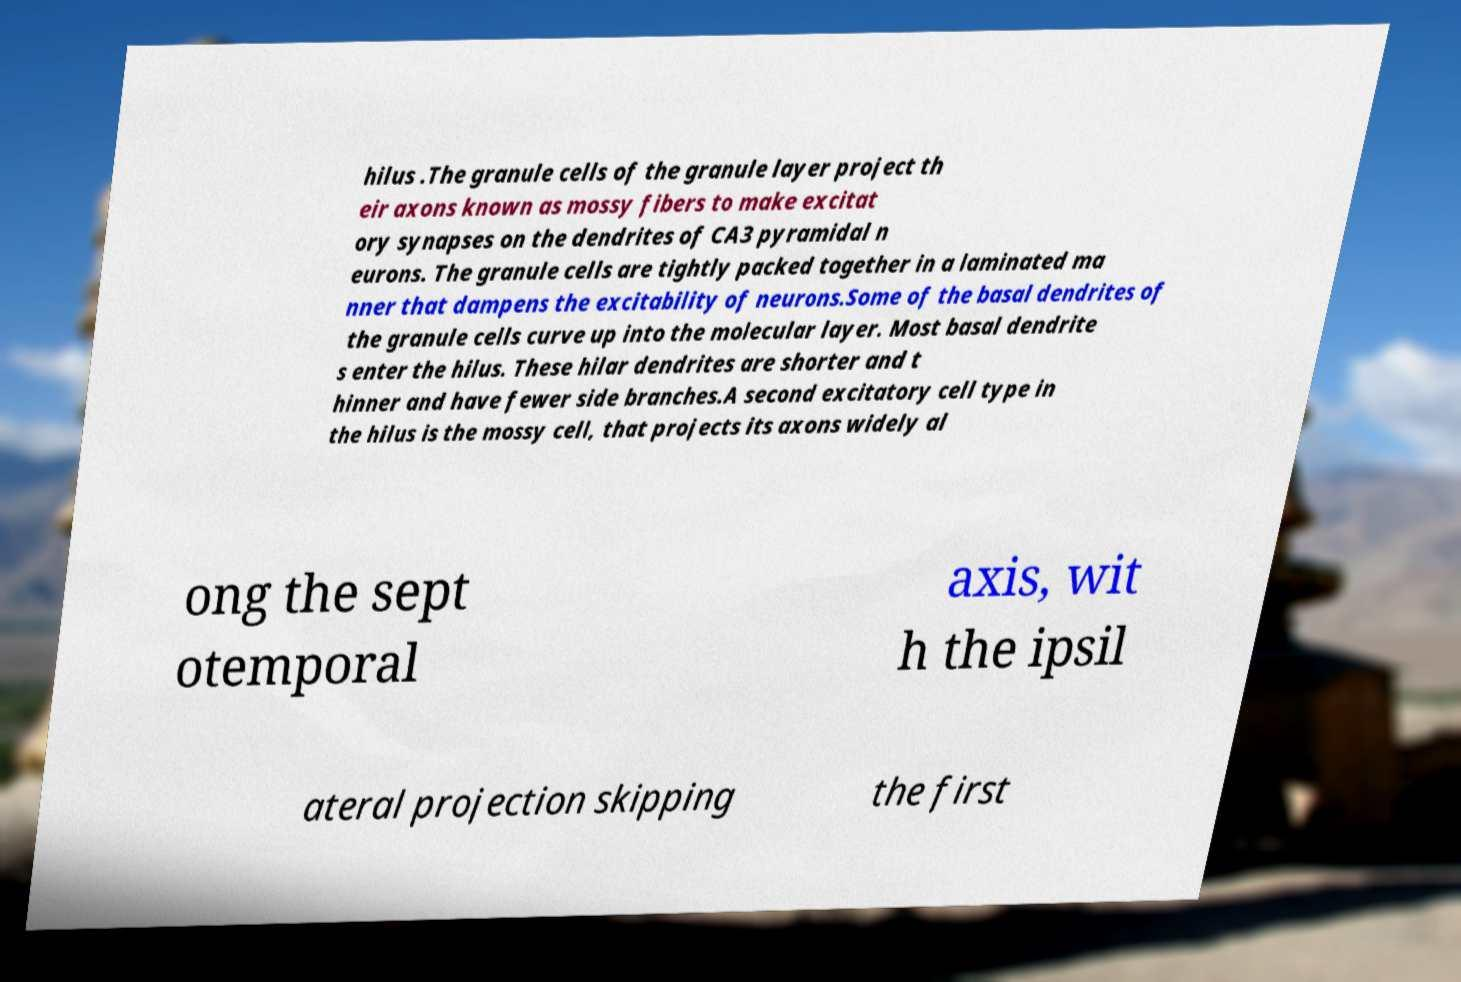Can you read and provide the text displayed in the image?This photo seems to have some interesting text. Can you extract and type it out for me? hilus .The granule cells of the granule layer project th eir axons known as mossy fibers to make excitat ory synapses on the dendrites of CA3 pyramidal n eurons. The granule cells are tightly packed together in a laminated ma nner that dampens the excitability of neurons.Some of the basal dendrites of the granule cells curve up into the molecular layer. Most basal dendrite s enter the hilus. These hilar dendrites are shorter and t hinner and have fewer side branches.A second excitatory cell type in the hilus is the mossy cell, that projects its axons widely al ong the sept otemporal axis, wit h the ipsil ateral projection skipping the first 